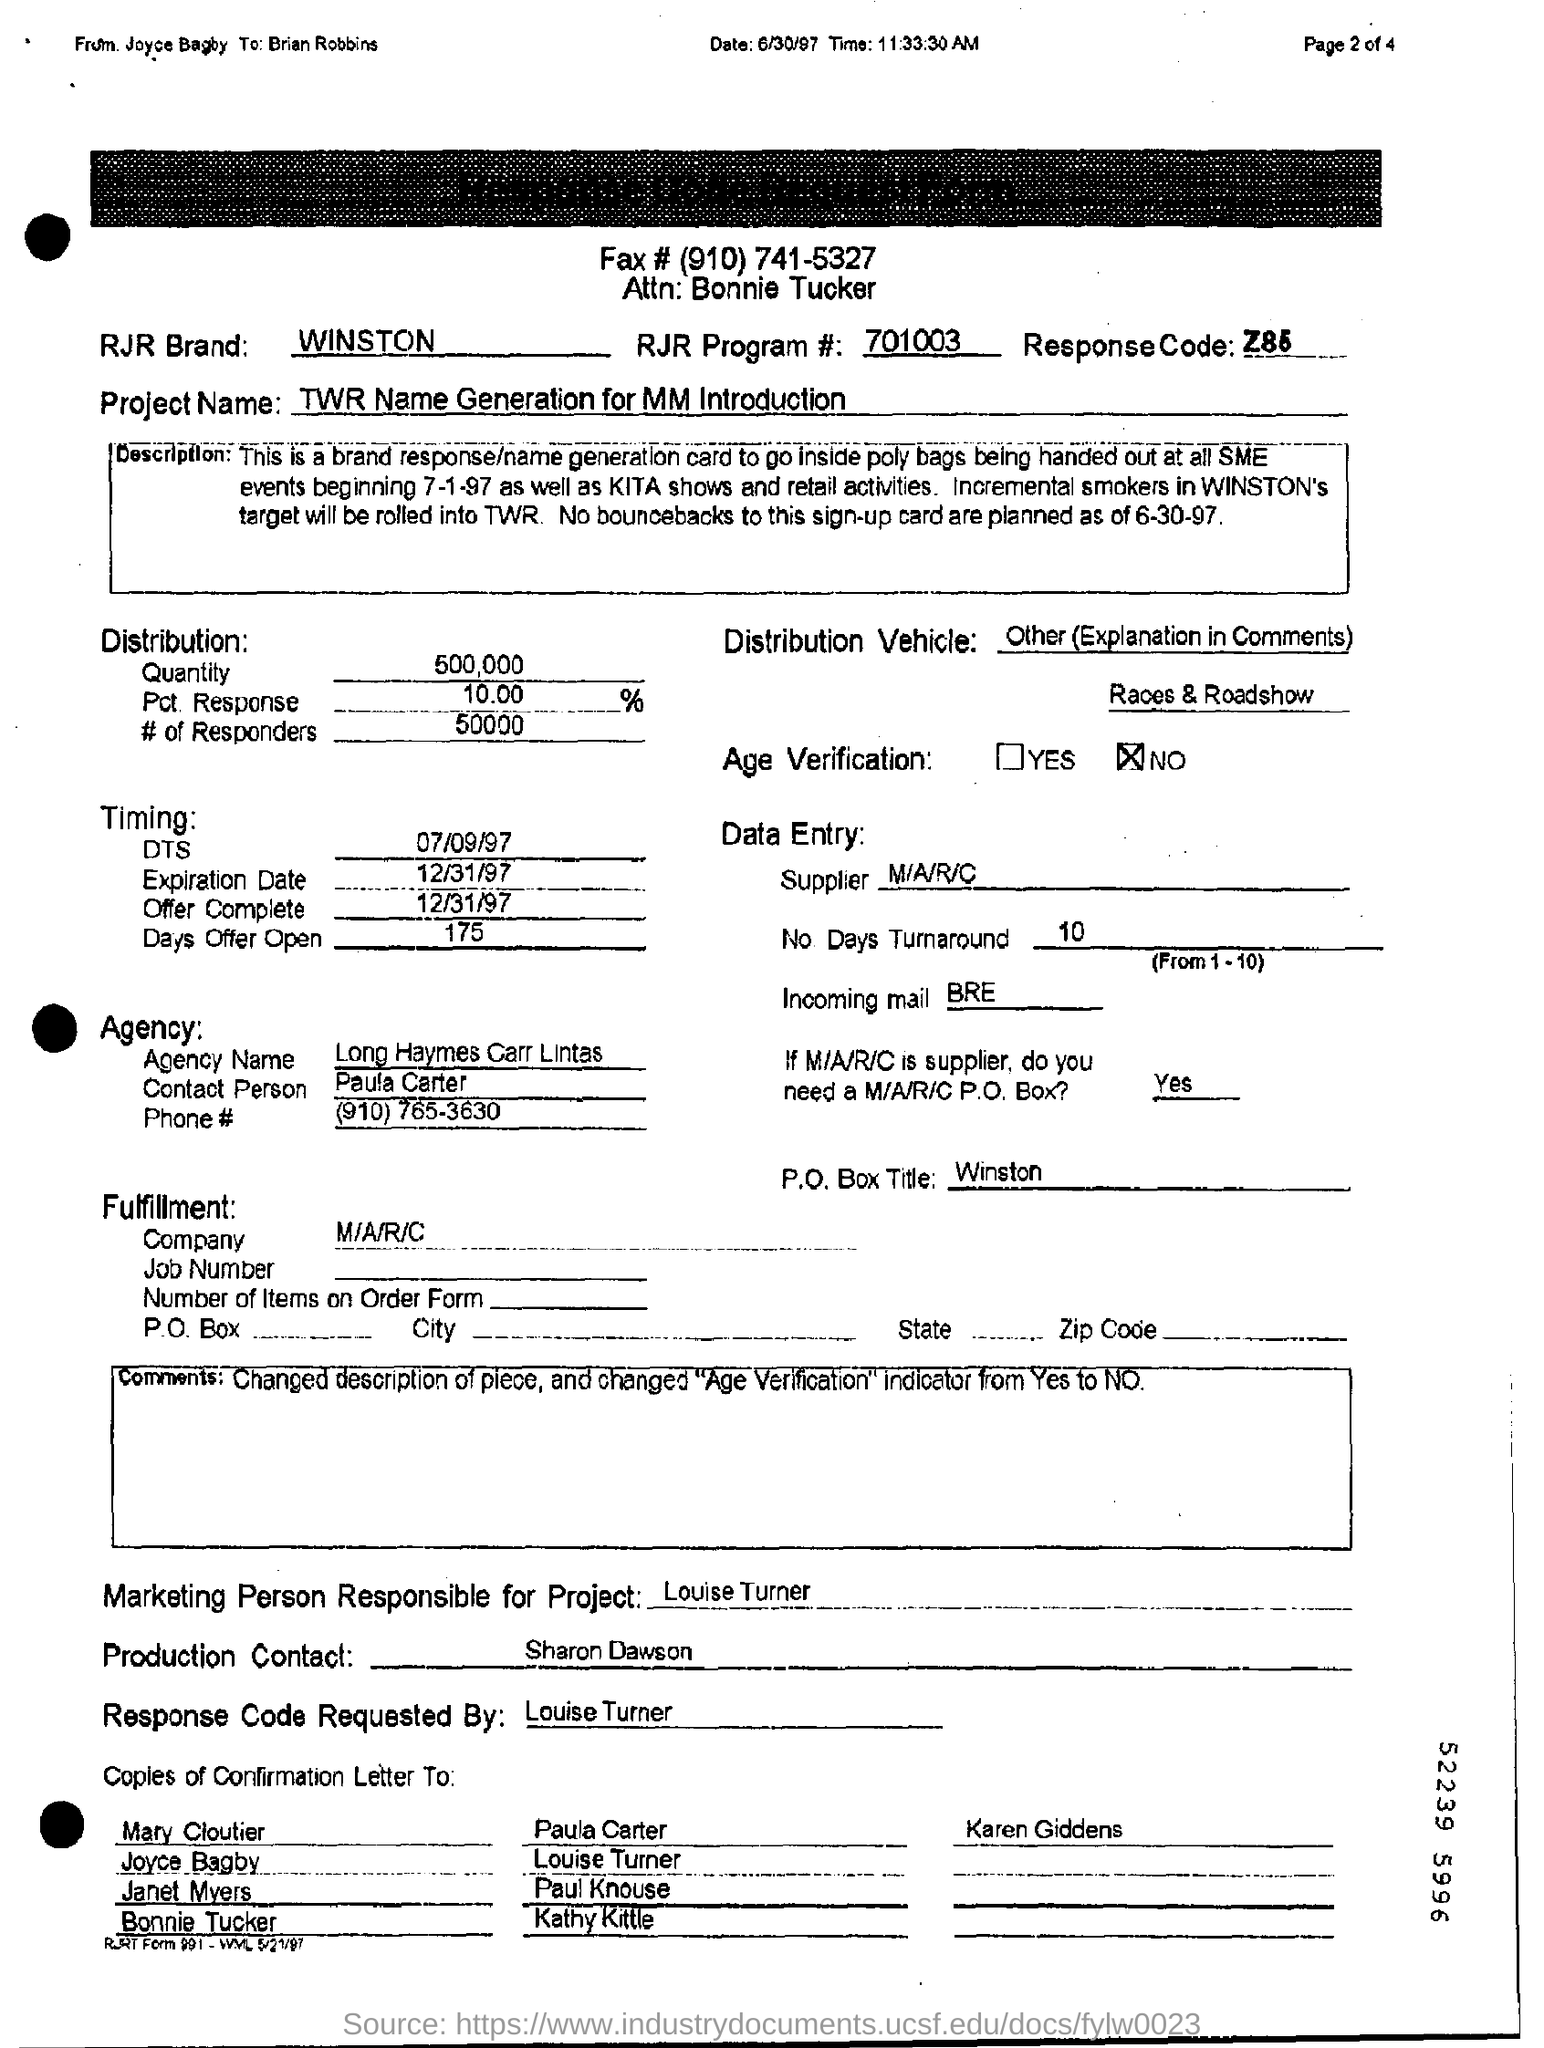What is the name of the project?
Make the answer very short. TWR Name Generation for MM Introduction. What is the agency name?
Make the answer very short. Long Haymes Carr Lintas. Who is the marketing person responsible for project?
Ensure brevity in your answer.  Louise Turner. Is there any age verification in the given fax?
Your answer should be very brief. No. 